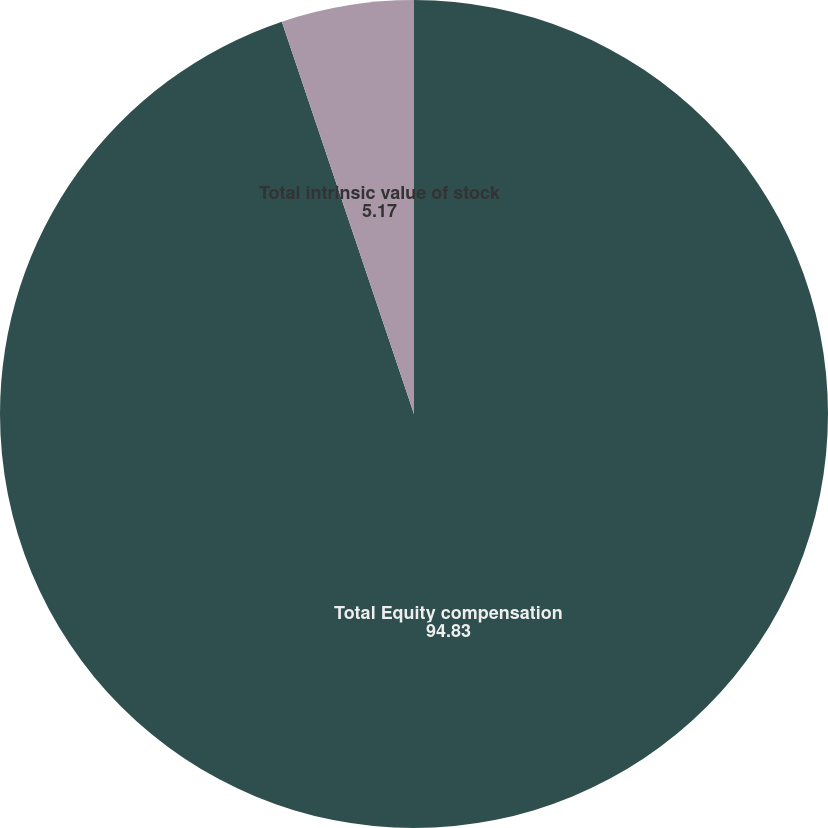Convert chart. <chart><loc_0><loc_0><loc_500><loc_500><pie_chart><fcel>Total Equity compensation<fcel>Total intrinsic value of stock<nl><fcel>94.83%<fcel>5.17%<nl></chart> 